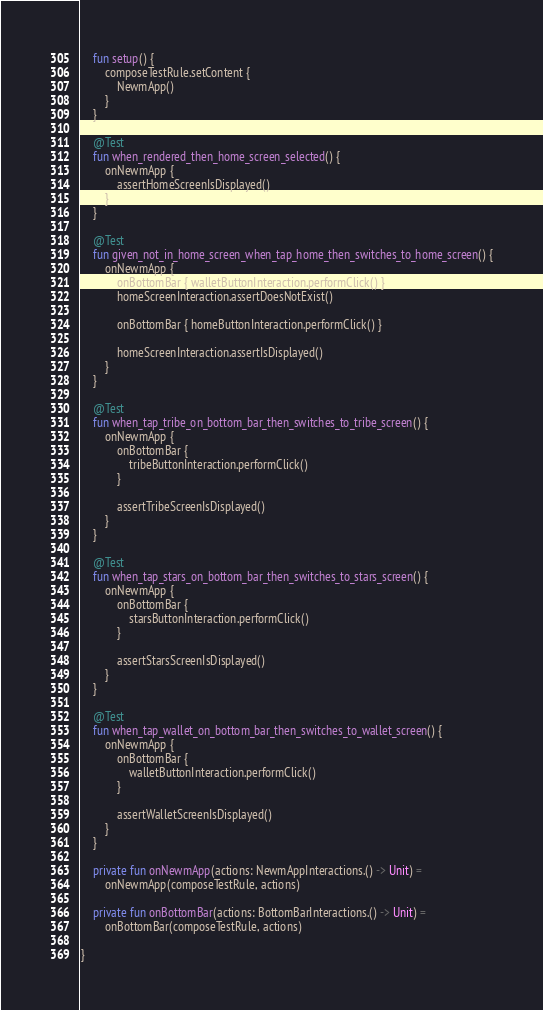<code> <loc_0><loc_0><loc_500><loc_500><_Kotlin_>    fun setup() {
        composeTestRule.setContent {
            NewmApp()
        }
    }

    @Test
    fun when_rendered_then_home_screen_selected() {
        onNewmApp {
            assertHomeScreenIsDisplayed()
        }
    }

    @Test
    fun given_not_in_home_screen_when_tap_home_then_switches_to_home_screen() {
        onNewmApp {
            onBottomBar { walletButtonInteraction.performClick() }
            homeScreenInteraction.assertDoesNotExist()

            onBottomBar { homeButtonInteraction.performClick() }

            homeScreenInteraction.assertIsDisplayed()
        }
    }

    @Test
    fun when_tap_tribe_on_bottom_bar_then_switches_to_tribe_screen() {
        onNewmApp {
            onBottomBar {
                tribeButtonInteraction.performClick()
            }

            assertTribeScreenIsDisplayed()
        }
    }

    @Test
    fun when_tap_stars_on_bottom_bar_then_switches_to_stars_screen() {
        onNewmApp {
            onBottomBar {
                starsButtonInteraction.performClick()
            }

            assertStarsScreenIsDisplayed()
        }
    }

    @Test
    fun when_tap_wallet_on_bottom_bar_then_switches_to_wallet_screen() {
        onNewmApp {
            onBottomBar {
                walletButtonInteraction.performClick()
            }

            assertWalletScreenIsDisplayed()
        }
    }

    private fun onNewmApp(actions: NewmAppInteractions.() -> Unit) =
        onNewmApp(composeTestRule, actions)

    private fun onBottomBar(actions: BottomBarInteractions.() -> Unit) =
        onBottomBar(composeTestRule, actions)

}</code> 